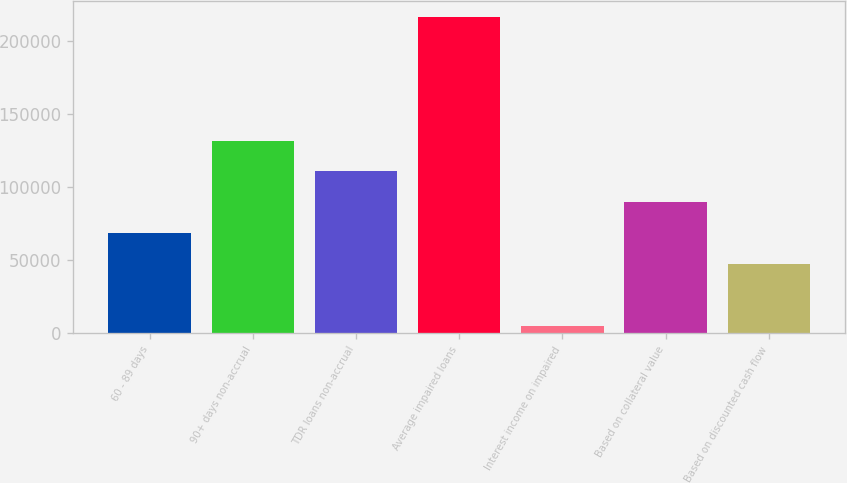<chart> <loc_0><loc_0><loc_500><loc_500><bar_chart><fcel>60 - 89 days<fcel>90+ days non-accrual<fcel>TDR loans non-accrual<fcel>Average impaired loans<fcel>Interest income on impaired<fcel>Based on collateral value<fcel>Based on discounted cash flow<nl><fcel>68366.2<fcel>131805<fcel>110659<fcel>216391<fcel>4927<fcel>89512.6<fcel>47219.8<nl></chart> 